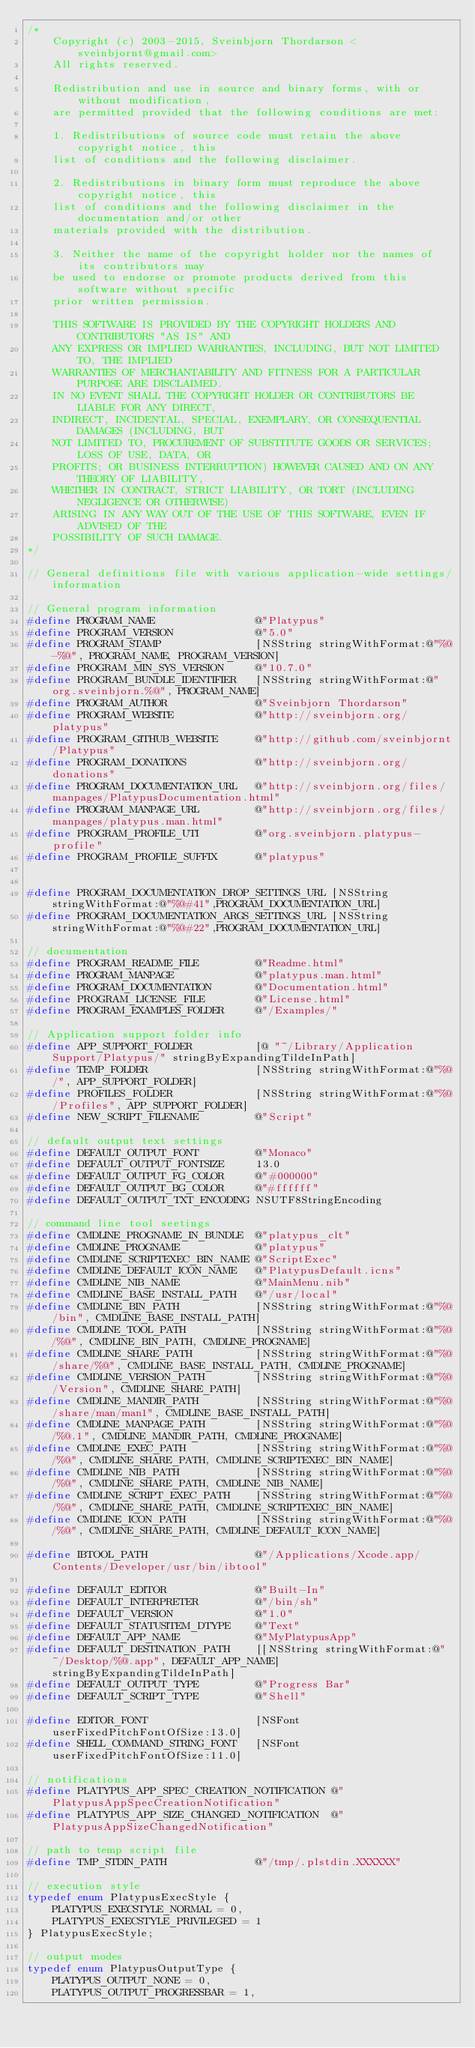Convert code to text. <code><loc_0><loc_0><loc_500><loc_500><_C_>/*
    Copyright (c) 2003-2015, Sveinbjorn Thordarson <sveinbjornt@gmail.com>
    All rights reserved.

    Redistribution and use in source and binary forms, with or without modification, 
    are permitted provided that the following conditions are met:
 
    1. Redistributions of source code must retain the above copyright notice, this 
    list of conditions and the following disclaimer.
 
    2. Redistributions in binary form must reproduce the above copyright notice, this 
    list of conditions and the following disclaimer in the documentation and/or other 
    materials provided with the distribution.
 
    3. Neither the name of the copyright holder nor the names of its contributors may 
    be used to endorse or promote products derived from this software without specific 
    prior written permission.
 
    THIS SOFTWARE IS PROVIDED BY THE COPYRIGHT HOLDERS AND CONTRIBUTORS "AS IS" AND 
    ANY EXPRESS OR IMPLIED WARRANTIES, INCLUDING, BUT NOT LIMITED TO, THE IMPLIED 
    WARRANTIES OF MERCHANTABILITY AND FITNESS FOR A PARTICULAR PURPOSE ARE DISCLAIMED. 
    IN NO EVENT SHALL THE COPYRIGHT HOLDER OR CONTRIBUTORS BE LIABLE FOR ANY DIRECT, 
    INDIRECT, INCIDENTAL, SPECIAL, EXEMPLARY, OR CONSEQUENTIAL DAMAGES (INCLUDING, BUT 
    NOT LIMITED TO, PROCUREMENT OF SUBSTITUTE GOODS OR SERVICES; LOSS OF USE, DATA, OR 
    PROFITS; OR BUSINESS INTERRUPTION) HOWEVER CAUSED AND ON ANY THEORY OF LIABILITY, 
    WHETHER IN CONTRACT, STRICT LIABILITY, OR TORT (INCLUDING NEGLIGENCE OR OTHERWISE) 
    ARISING IN ANY WAY OUT OF THE USE OF THIS SOFTWARE, EVEN IF ADVISED OF THE 
    POSSIBILITY OF SUCH DAMAGE.
*/

// General definitions file with various application-wide settings/information

// General program information
#define PROGRAM_NAME                @"Platypus"
#define PROGRAM_VERSION             @"5.0"
#define PROGRAM_STAMP               [NSString stringWithFormat:@"%@-%@", PROGRAM_NAME, PROGRAM_VERSION]
#define PROGRAM_MIN_SYS_VERSION     @"10.7.0"
#define PROGRAM_BUNDLE_IDENTIFIER   [NSString stringWithFormat:@"org.sveinbjorn.%@", PROGRAM_NAME]
#define PROGRAM_AUTHOR              @"Sveinbjorn Thordarson"
#define PROGRAM_WEBSITE             @"http://sveinbjorn.org/platypus"
#define PROGRAM_GITHUB_WEBSITE      @"http://github.com/sveinbjornt/Platypus"
#define PROGRAM_DONATIONS           @"http://sveinbjorn.org/donations"
#define PROGRAM_DOCUMENTATION_URL   @"http://sveinbjorn.org/files/manpages/PlatypusDocumentation.html"
#define PROGRAM_MANPAGE_URL         @"http://sveinbjorn.org/files/manpages/platypus.man.html"
#define PROGRAM_PROFILE_UTI         @"org.sveinbjorn.platypus-profile"
#define PROGRAM_PROFILE_SUFFIX      @"platypus"


#define PROGRAM_DOCUMENTATION_DROP_SETTINGS_URL [NSString stringWithFormat:@"%@#41",PROGRAM_DOCUMENTATION_URL]
#define PROGRAM_DOCUMENTATION_ARGS_SETTINGS_URL [NSString stringWithFormat:@"%@#22",PROGRAM_DOCUMENTATION_URL]

// documentation
#define PROGRAM_README_FILE         @"Readme.html"
#define PROGRAM_MANPAGE             @"platypus.man.html"
#define PROGRAM_DOCUMENTATION       @"Documentation.html"
#define PROGRAM_LICENSE_FILE        @"License.html"
#define PROGRAM_EXAMPLES_FOLDER     @"/Examples/"

// Application support folder info
#define APP_SUPPORT_FOLDER          [@ "~/Library/Application Support/Platypus/" stringByExpandingTildeInPath]
#define TEMP_FOLDER                 [NSString stringWithFormat:@"%@/", APP_SUPPORT_FOLDER]
#define PROFILES_FOLDER             [NSString stringWithFormat:@"%@/Profiles", APP_SUPPORT_FOLDER]
#define NEW_SCRIPT_FILENAME         @"Script"

// default output text settings
#define DEFAULT_OUTPUT_FONT         @"Monaco"
#define DEFAULT_OUTPUT_FONTSIZE     13.0
#define DEFAULT_OUTPUT_FG_COLOR     @"#000000"
#define DEFAULT_OUTPUT_BG_COLOR     @"#ffffff"
#define DEFAULT_OUTPUT_TXT_ENCODING NSUTF8StringEncoding

// command line tool seetings
#define CMDLINE_PROGNAME_IN_BUNDLE  @"platypus_clt"
#define CMDLINE_PROGNAME            @"platypus"
#define CMDLINE_SCRIPTEXEC_BIN_NAME @"ScriptExec"
#define CMDLINE_DEFAULT_ICON_NAME   @"PlatypusDefault.icns"
#define CMDLINE_NIB_NAME            @"MainMenu.nib"
#define CMDLINE_BASE_INSTALL_PATH   @"/usr/local"
#define CMDLINE_BIN_PATH            [NSString stringWithFormat:@"%@/bin", CMDLINE_BASE_INSTALL_PATH]
#define CMDLINE_TOOL_PATH           [NSString stringWithFormat:@"%@/%@", CMDLINE_BIN_PATH, CMDLINE_PROGNAME]
#define CMDLINE_SHARE_PATH          [NSString stringWithFormat:@"%@/share/%@", CMDLINE_BASE_INSTALL_PATH, CMDLINE_PROGNAME]
#define CMDLINE_VERSION_PATH        [NSString stringWithFormat:@"%@/Version", CMDLINE_SHARE_PATH]
#define CMDLINE_MANDIR_PATH         [NSString stringWithFormat:@"%@/share/man/man1", CMDLINE_BASE_INSTALL_PATH]
#define CMDLINE_MANPAGE_PATH        [NSString stringWithFormat:@"%@/%@.1", CMDLINE_MANDIR_PATH, CMDLINE_PROGNAME]
#define CMDLINE_EXEC_PATH           [NSString stringWithFormat:@"%@/%@", CMDLINE_SHARE_PATH, CMDLINE_SCRIPTEXEC_BIN_NAME]
#define CMDLINE_NIB_PATH            [NSString stringWithFormat:@"%@/%@", CMDLINE_SHARE_PATH, CMDLINE_NIB_NAME]
#define CMDLINE_SCRIPT_EXEC_PATH    [NSString stringWithFormat:@"%@/%@", CMDLINE_SHARE_PATH, CMDLINE_SCRIPTEXEC_BIN_NAME]
#define CMDLINE_ICON_PATH           [NSString stringWithFormat:@"%@/%@", CMDLINE_SHARE_PATH, CMDLINE_DEFAULT_ICON_NAME]

#define IBTOOL_PATH                 @"/Applications/Xcode.app/Contents/Developer/usr/bin/ibtool"

#define DEFAULT_EDITOR              @"Built-In"
#define DEFAULT_INTERPRETER         @"/bin/sh"
#define DEFAULT_VERSION             @"1.0"
#define DEFAULT_STATUSITEM_DTYPE    @"Text"
#define DEFAULT_APP_NAME            @"MyPlatypusApp"
#define DEFAULT_DESTINATION_PATH    [[NSString stringWithFormat:@"~/Desktop/%@.app", DEFAULT_APP_NAME] stringByExpandingTildeInPath]
#define DEFAULT_OUTPUT_TYPE         @"Progress Bar"
#define DEFAULT_SCRIPT_TYPE         @"Shell"

#define EDITOR_FONT                 [NSFont userFixedPitchFontOfSize:13.0]
#define SHELL_COMMAND_STRING_FONT   [NSFont userFixedPitchFontOfSize:11.0]

// notifications
#define PLATYPUS_APP_SPEC_CREATION_NOTIFICATION @"PlatypusAppSpecCreationNotification"
#define PLATYPUS_APP_SIZE_CHANGED_NOTIFICATION  @"PlatypusAppSizeChangedNotification"

// path to temp script file
#define TMP_STDIN_PATH              @"/tmp/.plstdin.XXXXXX"

// execution style
typedef enum PlatypusExecStyle {
    PLATYPUS_EXECSTYLE_NORMAL = 0,
    PLATYPUS_EXECSTYLE_PRIVILEGED = 1
} PlatypusExecStyle;

// output modes
typedef enum PlatypusOutputType {
    PLATYPUS_OUTPUT_NONE = 0,
    PLATYPUS_OUTPUT_PROGRESSBAR = 1,</code> 